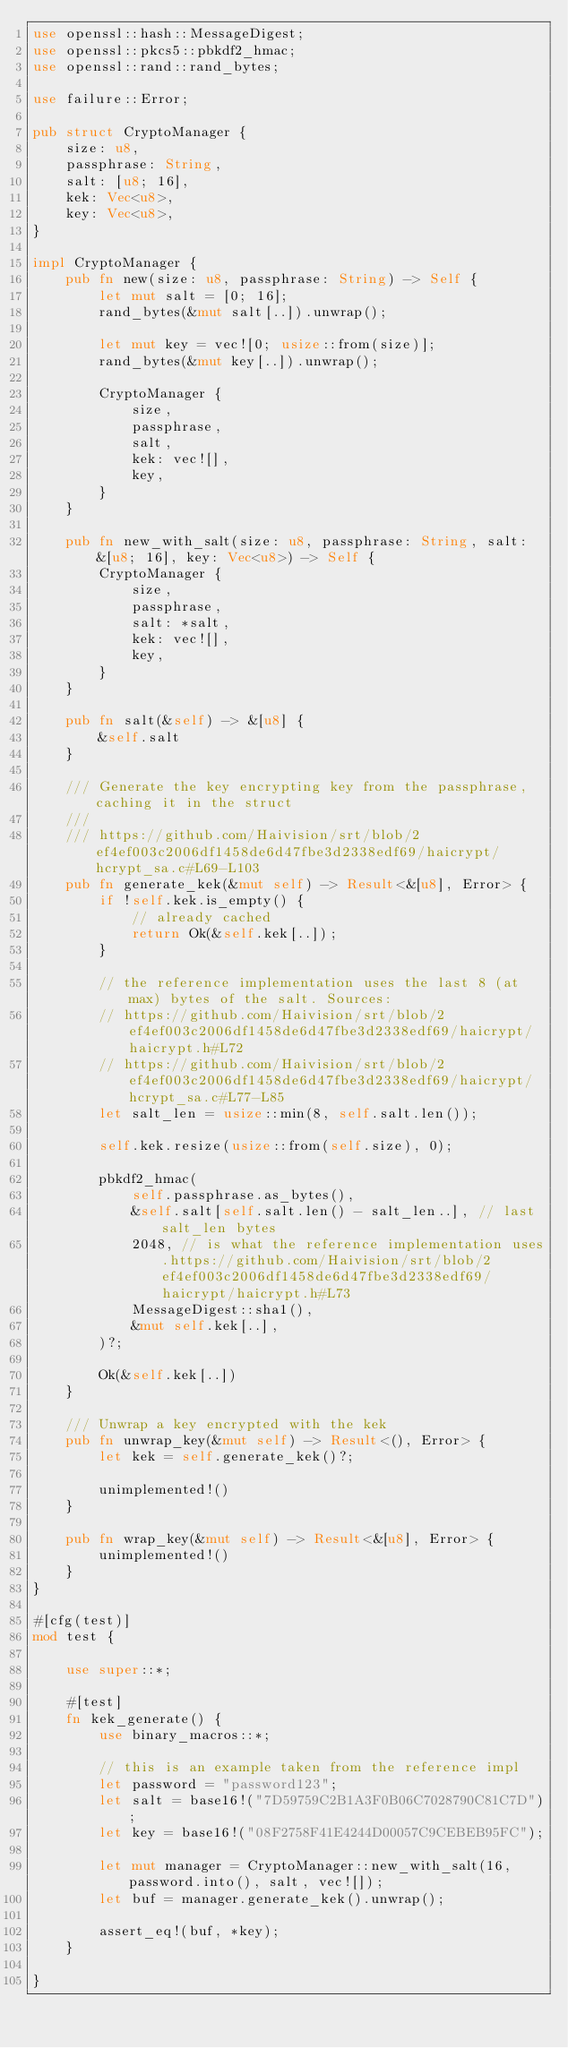<code> <loc_0><loc_0><loc_500><loc_500><_Rust_>use openssl::hash::MessageDigest;
use openssl::pkcs5::pbkdf2_hmac;
use openssl::rand::rand_bytes;

use failure::Error;

pub struct CryptoManager {
    size: u8,
    passphrase: String,
    salt: [u8; 16],
    kek: Vec<u8>,
    key: Vec<u8>,
}

impl CryptoManager {
    pub fn new(size: u8, passphrase: String) -> Self {
        let mut salt = [0; 16];
        rand_bytes(&mut salt[..]).unwrap();

        let mut key = vec![0; usize::from(size)];
        rand_bytes(&mut key[..]).unwrap();

        CryptoManager {
            size,
            passphrase,
            salt,
            kek: vec![],
            key,
        }
    }

    pub fn new_with_salt(size: u8, passphrase: String, salt: &[u8; 16], key: Vec<u8>) -> Self {
        CryptoManager {
            size,
            passphrase,
            salt: *salt,
            kek: vec![],
            key,
        }
    }

    pub fn salt(&self) -> &[u8] {
        &self.salt
    }

    /// Generate the key encrypting key from the passphrase, caching it in the struct
    ///
    /// https://github.com/Haivision/srt/blob/2ef4ef003c2006df1458de6d47fbe3d2338edf69/haicrypt/hcrypt_sa.c#L69-L103
    pub fn generate_kek(&mut self) -> Result<&[u8], Error> {
        if !self.kek.is_empty() {
            // already cached
            return Ok(&self.kek[..]);
        }

        // the reference implementation uses the last 8 (at max) bytes of the salt. Sources:
        // https://github.com/Haivision/srt/blob/2ef4ef003c2006df1458de6d47fbe3d2338edf69/haicrypt/haicrypt.h#L72
        // https://github.com/Haivision/srt/blob/2ef4ef003c2006df1458de6d47fbe3d2338edf69/haicrypt/hcrypt_sa.c#L77-L85
        let salt_len = usize::min(8, self.salt.len());

        self.kek.resize(usize::from(self.size), 0);

        pbkdf2_hmac(
            self.passphrase.as_bytes(),
            &self.salt[self.salt.len() - salt_len..], // last salt_len bytes
            2048, // is what the reference implementation uses.https://github.com/Haivision/srt/blob/2ef4ef003c2006df1458de6d47fbe3d2338edf69/haicrypt/haicrypt.h#L73
            MessageDigest::sha1(),
            &mut self.kek[..],
        )?;

        Ok(&self.kek[..])
    }

    /// Unwrap a key encrypted with the kek
    pub fn unwrap_key(&mut self) -> Result<(), Error> {
        let kek = self.generate_kek()?;

        unimplemented!()
    }

    pub fn wrap_key(&mut self) -> Result<&[u8], Error> {
        unimplemented!()
    }
}

#[cfg(test)]
mod test {

    use super::*;

    #[test]
    fn kek_generate() {
        use binary_macros::*;

        // this is an example taken from the reference impl
        let password = "password123";
        let salt = base16!("7D59759C2B1A3F0B06C7028790C81C7D");
        let key = base16!("08F2758F41E4244D00057C9CEBEB95FC");

        let mut manager = CryptoManager::new_with_salt(16, password.into(), salt, vec![]);
        let buf = manager.generate_kek().unwrap();

        assert_eq!(buf, *key);
    }

}
</code> 